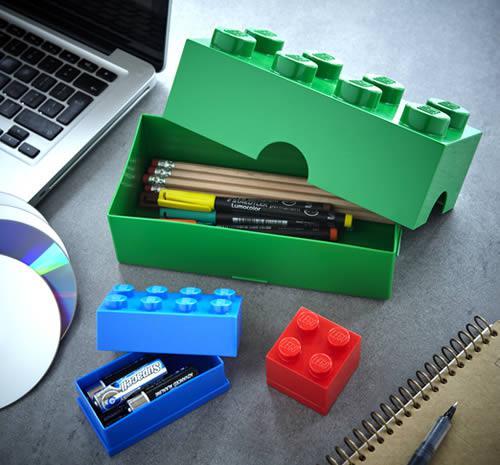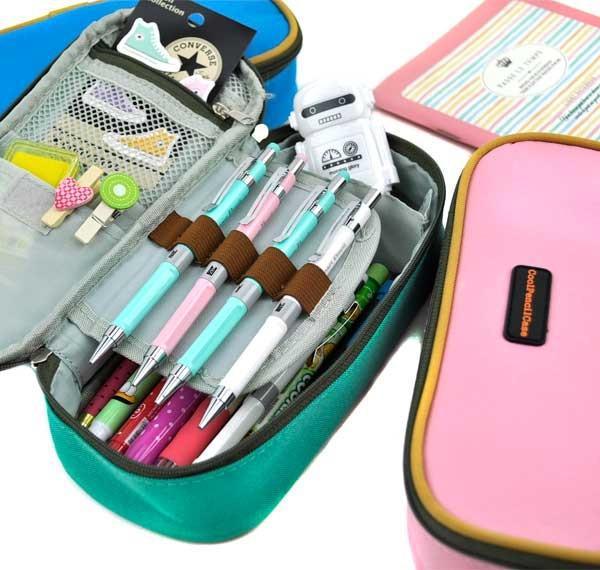The first image is the image on the left, the second image is the image on the right. For the images displayed, is the sentence "One of the cases in the image on the right is open." factually correct? Answer yes or no. Yes. 